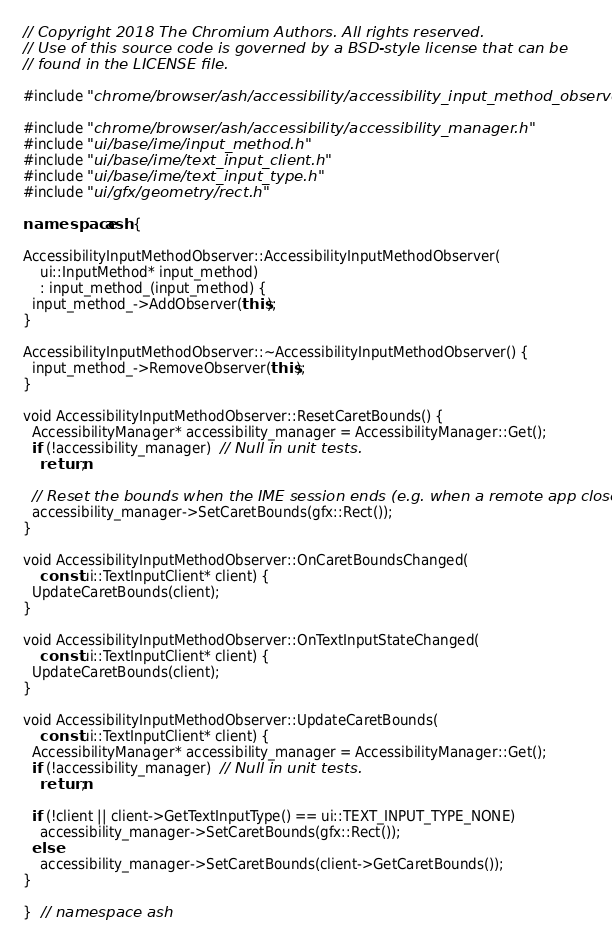Convert code to text. <code><loc_0><loc_0><loc_500><loc_500><_C++_>// Copyright 2018 The Chromium Authors. All rights reserved.
// Use of this source code is governed by a BSD-style license that can be
// found in the LICENSE file.

#include "chrome/browser/ash/accessibility/accessibility_input_method_observer.h"

#include "chrome/browser/ash/accessibility/accessibility_manager.h"
#include "ui/base/ime/input_method.h"
#include "ui/base/ime/text_input_client.h"
#include "ui/base/ime/text_input_type.h"
#include "ui/gfx/geometry/rect.h"

namespace ash {

AccessibilityInputMethodObserver::AccessibilityInputMethodObserver(
    ui::InputMethod* input_method)
    : input_method_(input_method) {
  input_method_->AddObserver(this);
}

AccessibilityInputMethodObserver::~AccessibilityInputMethodObserver() {
  input_method_->RemoveObserver(this);
}

void AccessibilityInputMethodObserver::ResetCaretBounds() {
  AccessibilityManager* accessibility_manager = AccessibilityManager::Get();
  if (!accessibility_manager)  // Null in unit tests.
    return;

  // Reset the bounds when the IME session ends (e.g. when a remote app closes).
  accessibility_manager->SetCaretBounds(gfx::Rect());
}

void AccessibilityInputMethodObserver::OnCaretBoundsChanged(
    const ui::TextInputClient* client) {
  UpdateCaretBounds(client);
}

void AccessibilityInputMethodObserver::OnTextInputStateChanged(
    const ui::TextInputClient* client) {
  UpdateCaretBounds(client);
}

void AccessibilityInputMethodObserver::UpdateCaretBounds(
    const ui::TextInputClient* client) {
  AccessibilityManager* accessibility_manager = AccessibilityManager::Get();
  if (!accessibility_manager)  // Null in unit tests.
    return;

  if (!client || client->GetTextInputType() == ui::TEXT_INPUT_TYPE_NONE)
    accessibility_manager->SetCaretBounds(gfx::Rect());
  else
    accessibility_manager->SetCaretBounds(client->GetCaretBounds());
}

}  // namespace ash
</code> 